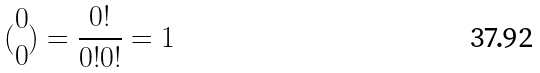<formula> <loc_0><loc_0><loc_500><loc_500>( \begin{matrix} 0 \\ 0 \end{matrix} ) = \frac { 0 ! } { 0 ! 0 ! } = 1</formula> 